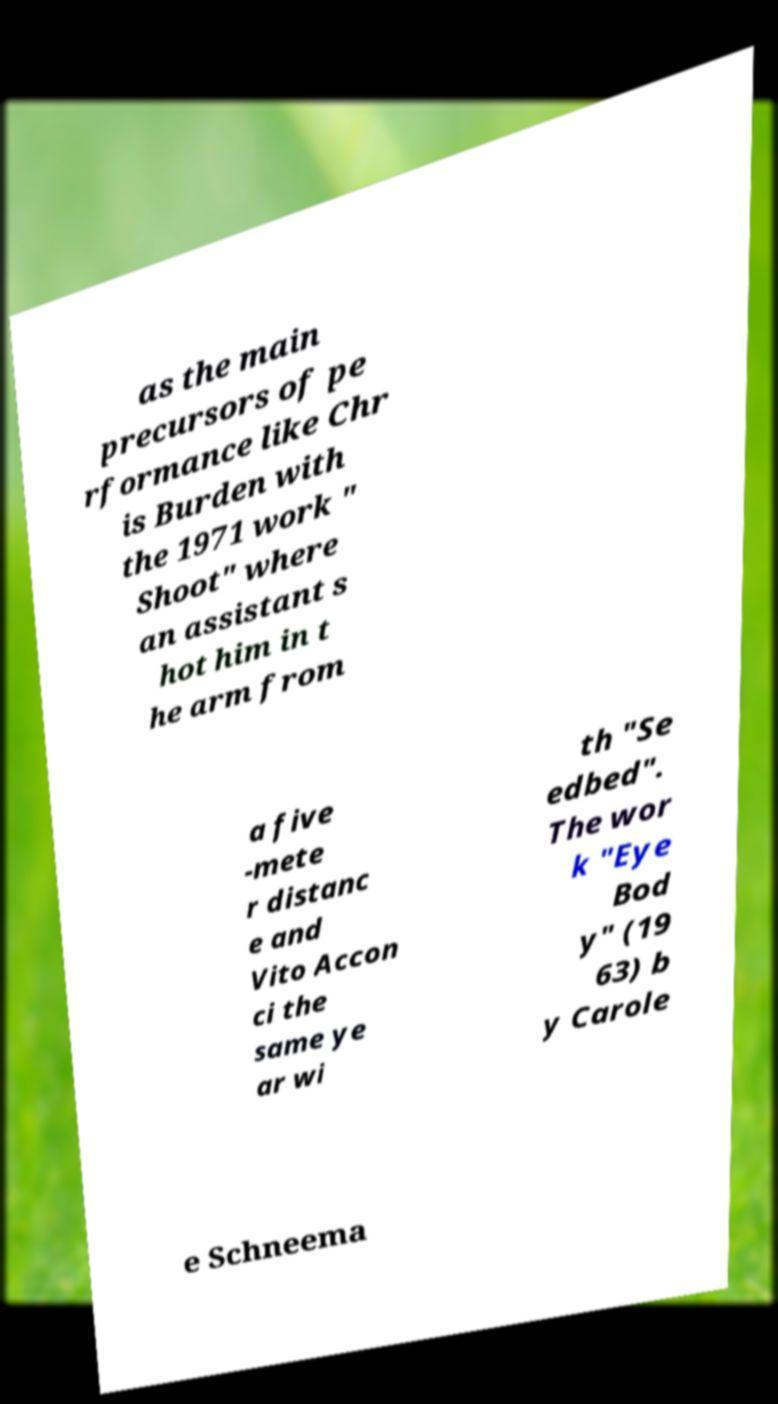There's text embedded in this image that I need extracted. Can you transcribe it verbatim? as the main precursors of pe rformance like Chr is Burden with the 1971 work " Shoot" where an assistant s hot him in t he arm from a five -mete r distanc e and Vito Accon ci the same ye ar wi th "Se edbed". The wor k "Eye Bod y" (19 63) b y Carole e Schneema 